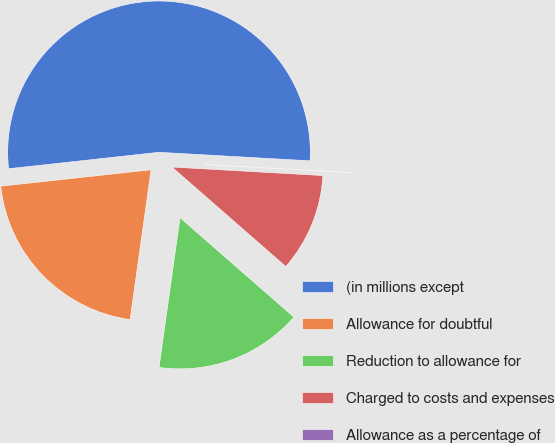Convert chart. <chart><loc_0><loc_0><loc_500><loc_500><pie_chart><fcel>(in millions except<fcel>Allowance for doubtful<fcel>Reduction to allowance for<fcel>Charged to costs and expenses<fcel>Allowance as a percentage of<nl><fcel>52.63%<fcel>21.05%<fcel>15.79%<fcel>10.53%<fcel>0.0%<nl></chart> 